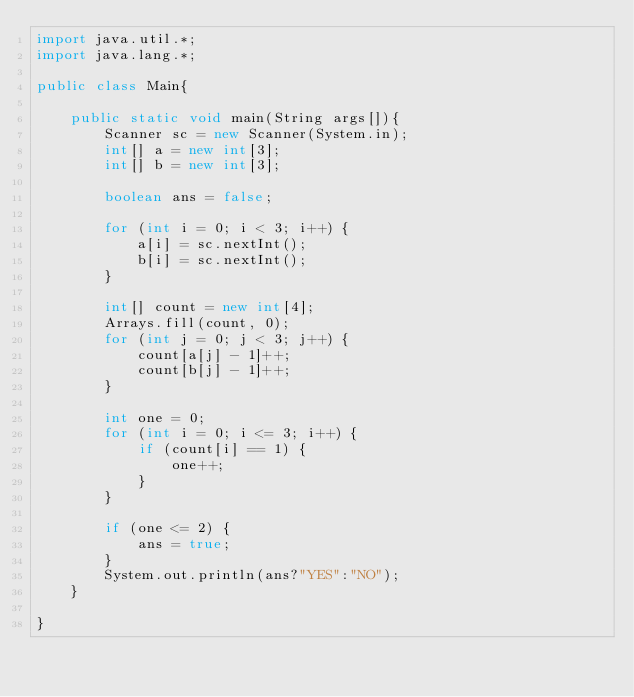Convert code to text. <code><loc_0><loc_0><loc_500><loc_500><_Java_>import java.util.*;
import java.lang.*;

public class Main{
    
    public static void main(String args[]){
        Scanner sc = new Scanner(System.in);
        int[] a = new int[3];
        int[] b = new int[3];

        boolean ans = false;
        
        for (int i = 0; i < 3; i++) {
            a[i] = sc.nextInt();
            b[i] = sc.nextInt();
        }
        
        int[] count = new int[4];
        Arrays.fill(count, 0);
        for (int j = 0; j < 3; j++) {
            count[a[j] - 1]++;
            count[b[j] - 1]++;
        }
        
        int one = 0;
        for (int i = 0; i <= 3; i++) {
            if (count[i] == 1) {
                one++;
            }
        }
        
        if (one <= 2) {
            ans = true;
        }
        System.out.println(ans?"YES":"NO");
    }

}</code> 